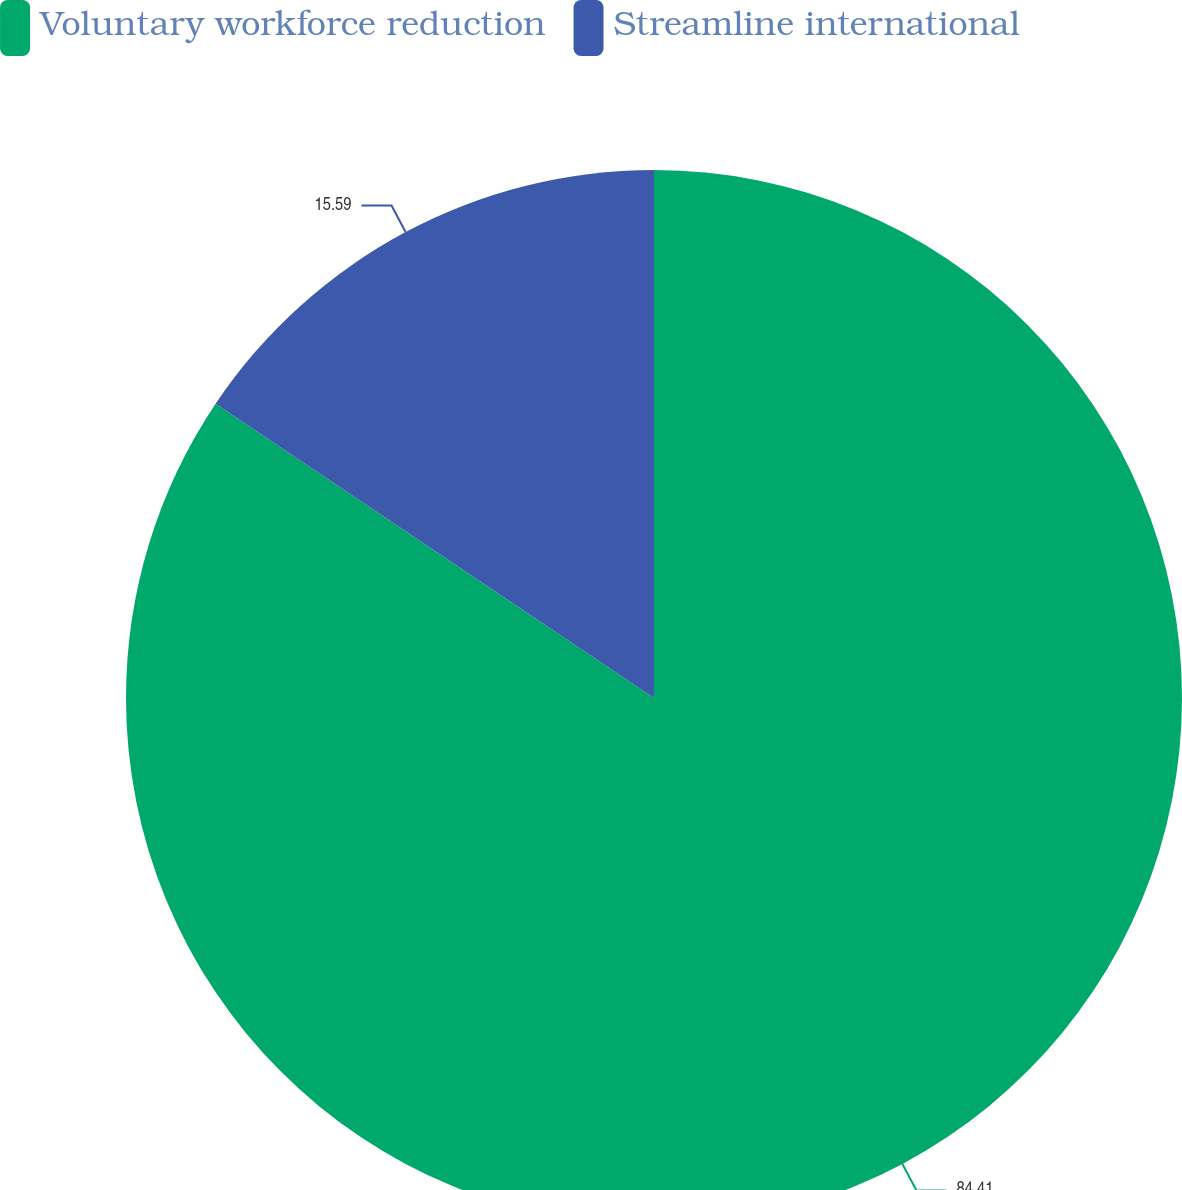<chart> <loc_0><loc_0><loc_500><loc_500><pie_chart><fcel>Voluntary workforce reduction<fcel>Streamline international<nl><fcel>84.41%<fcel>15.59%<nl></chart> 